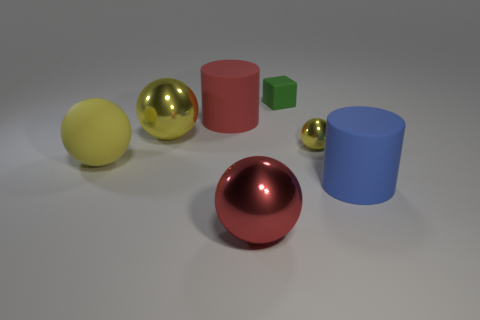There is a red metal thing; is its shape the same as the yellow object that is right of the tiny matte object?
Offer a very short reply. Yes. Is there anything else that has the same size as the green object?
Your response must be concise. Yes. There is another rubber thing that is the same shape as the red rubber object; what is its size?
Provide a succinct answer. Large. Is the number of yellow things greater than the number of big yellow shiny objects?
Ensure brevity in your answer.  Yes. Is the shape of the large blue matte thing the same as the tiny yellow thing?
Provide a short and direct response. No. What is the material of the big sphere that is in front of the large object that is on the right side of the tiny shiny ball?
Your answer should be very brief. Metal. There is a small ball that is the same color as the big rubber sphere; what material is it?
Offer a very short reply. Metal. Is the green thing the same size as the red shiny ball?
Offer a terse response. No. Is there a red ball behind the tiny thing right of the small green object?
Keep it short and to the point. No. What is the size of the rubber object that is the same color as the small metallic thing?
Your answer should be compact. Large. 